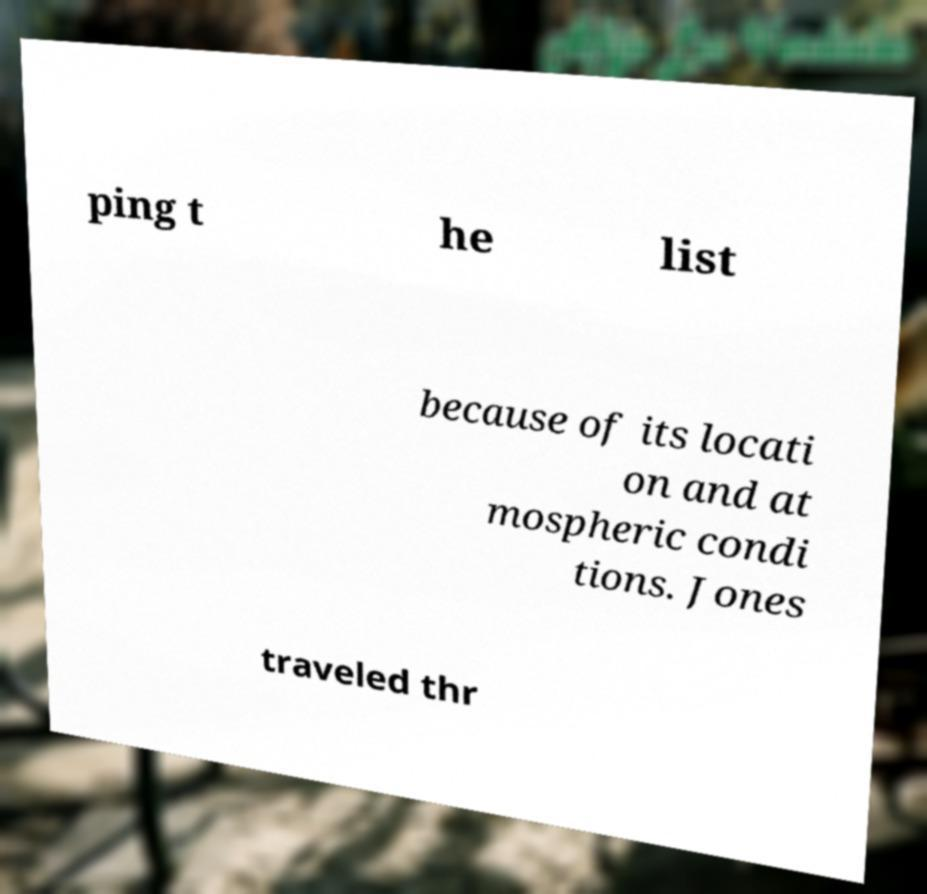Please read and relay the text visible in this image. What does it say? ping t he list because of its locati on and at mospheric condi tions. Jones traveled thr 